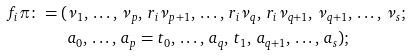<formula> <loc_0><loc_0><loc_500><loc_500>f _ { i } \pi \colon = ( & \nu _ { 1 } , \, \dots , \, \nu _ { p } , \, r _ { i } \nu _ { p + 1 } , \, \dots , \, r _ { i } \nu _ { q } , \, r _ { i } \nu _ { q + 1 } , \, \nu _ { q + 1 } , \, \dots , \, \nu _ { s } ; \\ & a _ { 0 } , \, \dots , \, a _ { p } = t _ { 0 } , \, \dots , \, a _ { q } , \, t _ { 1 } , \, a _ { q + 1 } , \, \dots , \, a _ { s } ) ;</formula> 